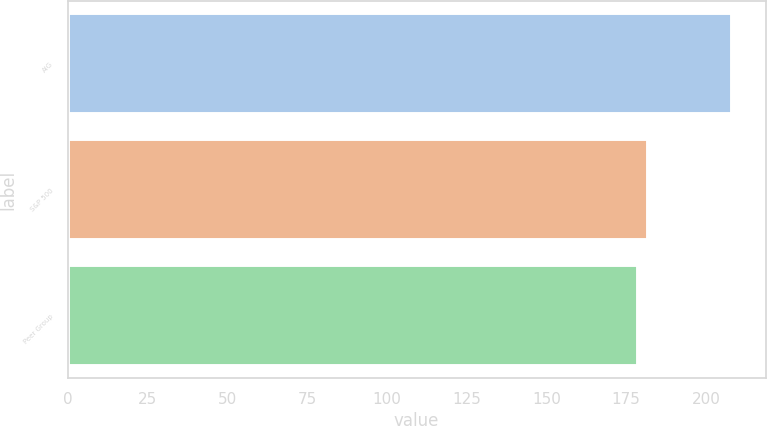Convert chart to OTSL. <chart><loc_0><loc_0><loc_500><loc_500><bar_chart><fcel>AIG<fcel>S&P 500<fcel>Peer Group<nl><fcel>208.29<fcel>181.75<fcel>178.8<nl></chart> 